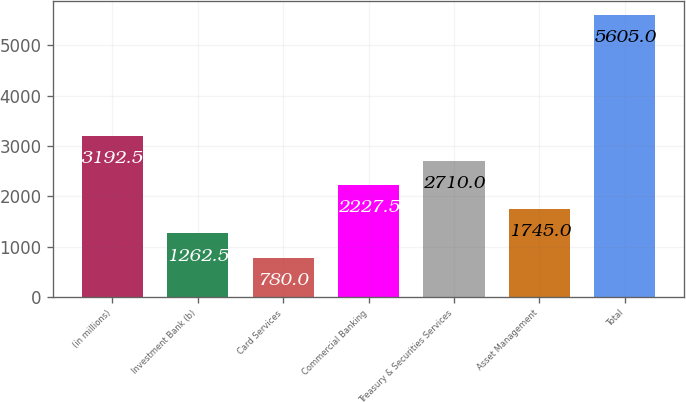Convert chart. <chart><loc_0><loc_0><loc_500><loc_500><bar_chart><fcel>(in millions)<fcel>Investment Bank (b)<fcel>Card Services<fcel>Commercial Banking<fcel>Treasury & Securities Services<fcel>Asset Management<fcel>Total<nl><fcel>3192.5<fcel>1262.5<fcel>780<fcel>2227.5<fcel>2710<fcel>1745<fcel>5605<nl></chart> 